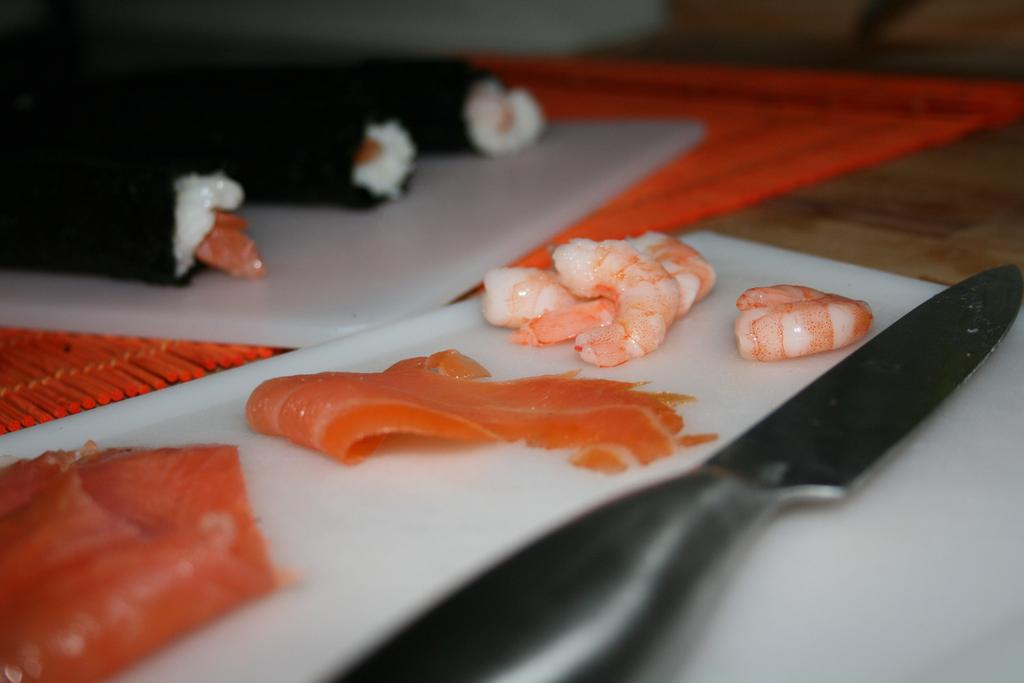What is on the plate in the image? There are eatable items on a plate in the image. What utensil can be seen in the image? There is a knife present in the image. How many dolls are playing in the yard in the image? There are no dolls or yards present in the image; it only features a plate with eatable items and a knife. 